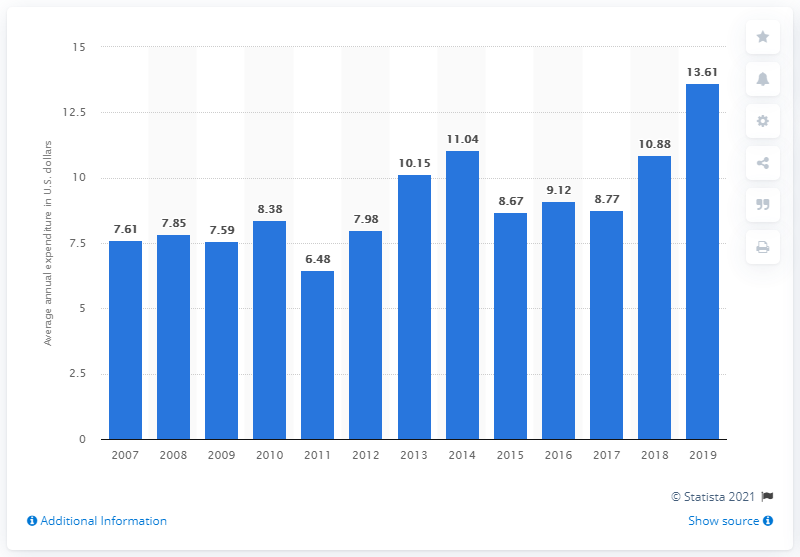Identify some key points in this picture. In 2019, the average expenditure on microwave ovens per consumer unit in the United States was $13.61. 